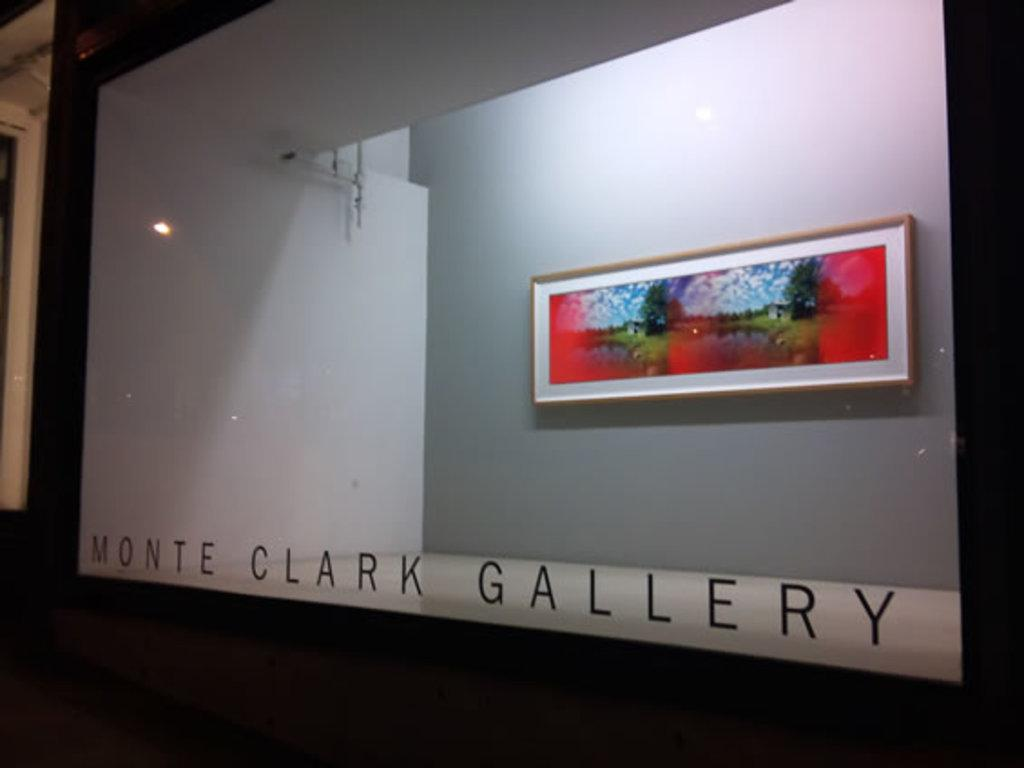<image>
Offer a succinct explanation of the picture presented. A display of the Monte Clark Gallery and a painting brought by it. 